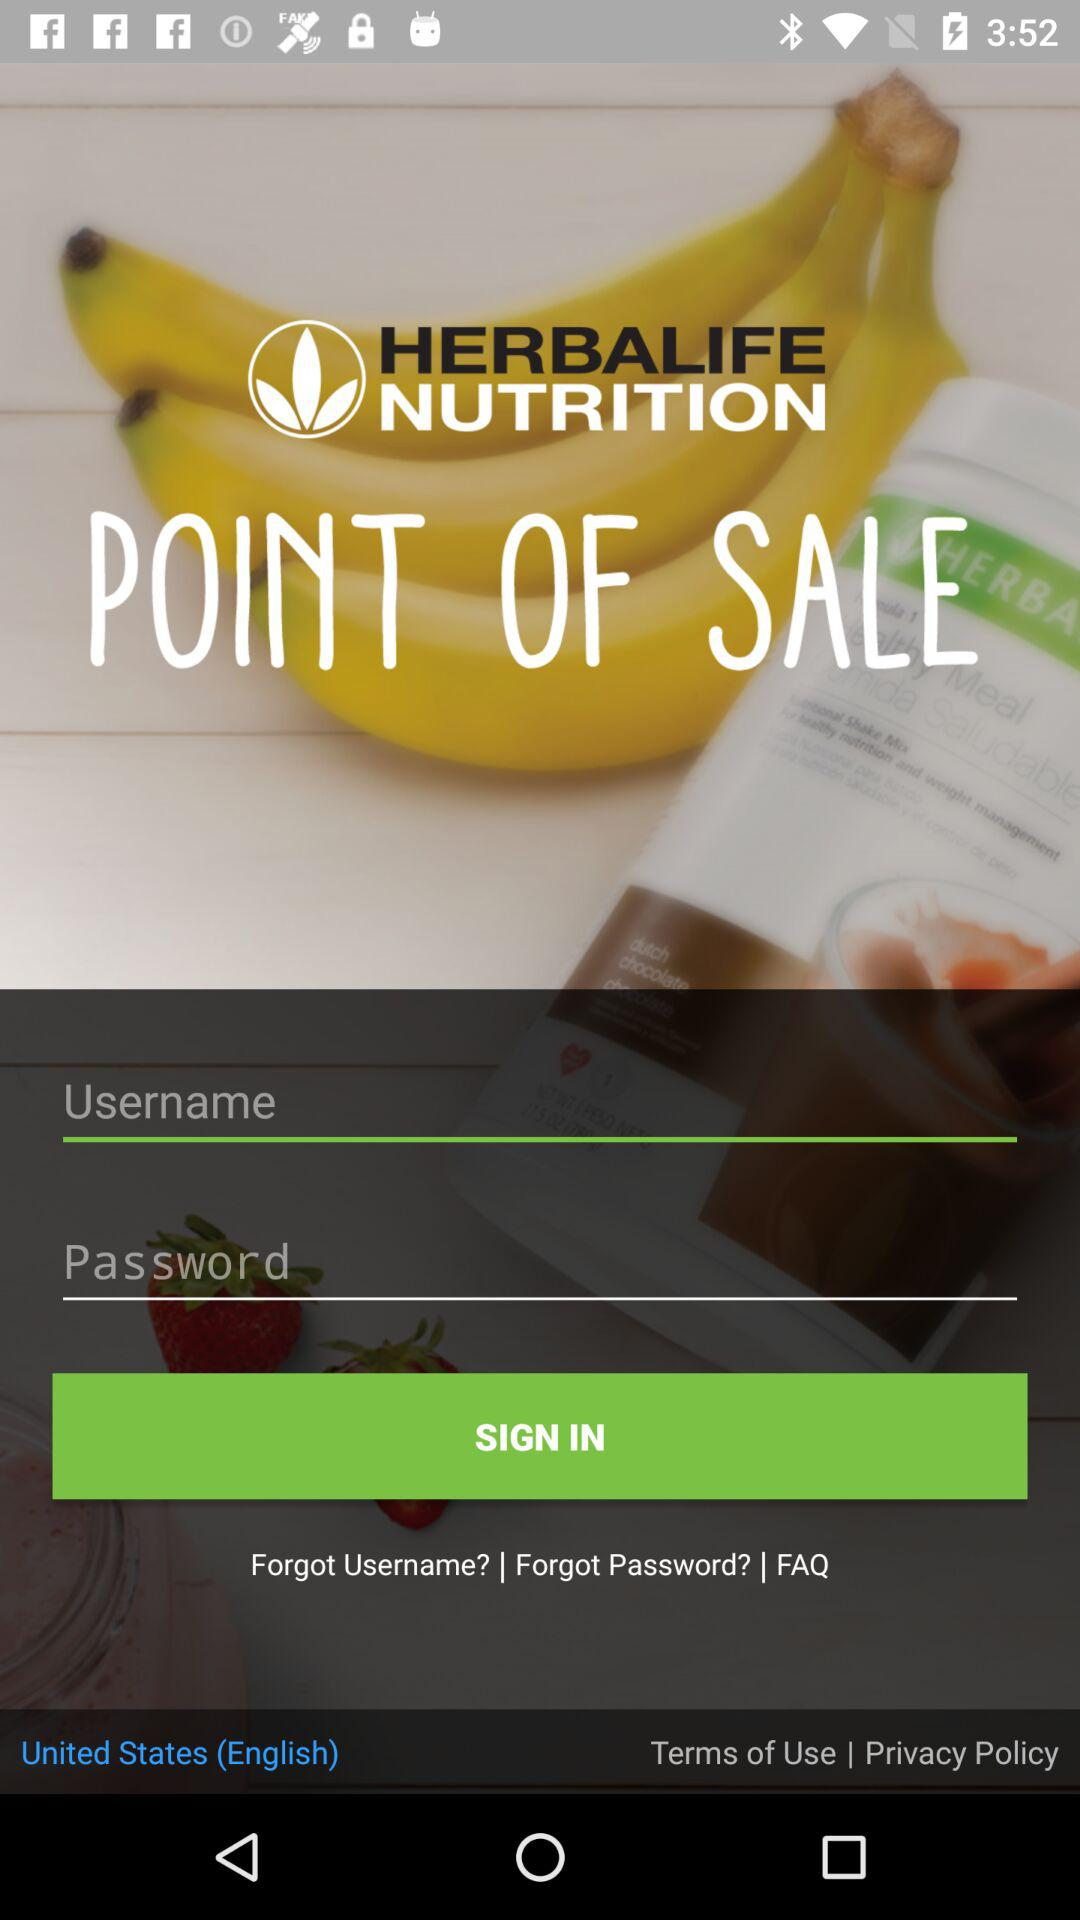What is the selected language? The selected language is "United States (English)". 